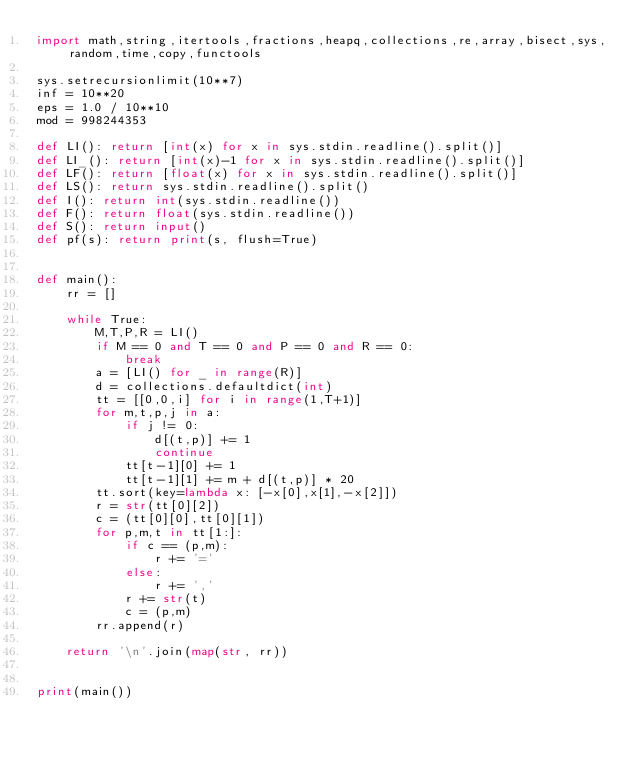<code> <loc_0><loc_0><loc_500><loc_500><_Python_>import math,string,itertools,fractions,heapq,collections,re,array,bisect,sys,random,time,copy,functools

sys.setrecursionlimit(10**7)
inf = 10**20
eps = 1.0 / 10**10
mod = 998244353

def LI(): return [int(x) for x in sys.stdin.readline().split()]
def LI_(): return [int(x)-1 for x in sys.stdin.readline().split()]
def LF(): return [float(x) for x in sys.stdin.readline().split()]
def LS(): return sys.stdin.readline().split()
def I(): return int(sys.stdin.readline())
def F(): return float(sys.stdin.readline())
def S(): return input()
def pf(s): return print(s, flush=True)


def main():
    rr = []

    while True:
        M,T,P,R = LI()
        if M == 0 and T == 0 and P == 0 and R == 0:
            break
        a = [LI() for _ in range(R)]
        d = collections.defaultdict(int)
        tt = [[0,0,i] for i in range(1,T+1)]
        for m,t,p,j in a:
            if j != 0:
                d[(t,p)] += 1
                continue
            tt[t-1][0] += 1
            tt[t-1][1] += m + d[(t,p)] * 20
        tt.sort(key=lambda x: [-x[0],x[1],-x[2]])
        r = str(tt[0][2])
        c = (tt[0][0],tt[0][1])
        for p,m,t in tt[1:]:
            if c == (p,m):
                r += '='
            else:
                r += ','
            r += str(t)
            c = (p,m)
        rr.append(r)

    return '\n'.join(map(str, rr))


print(main())


</code> 